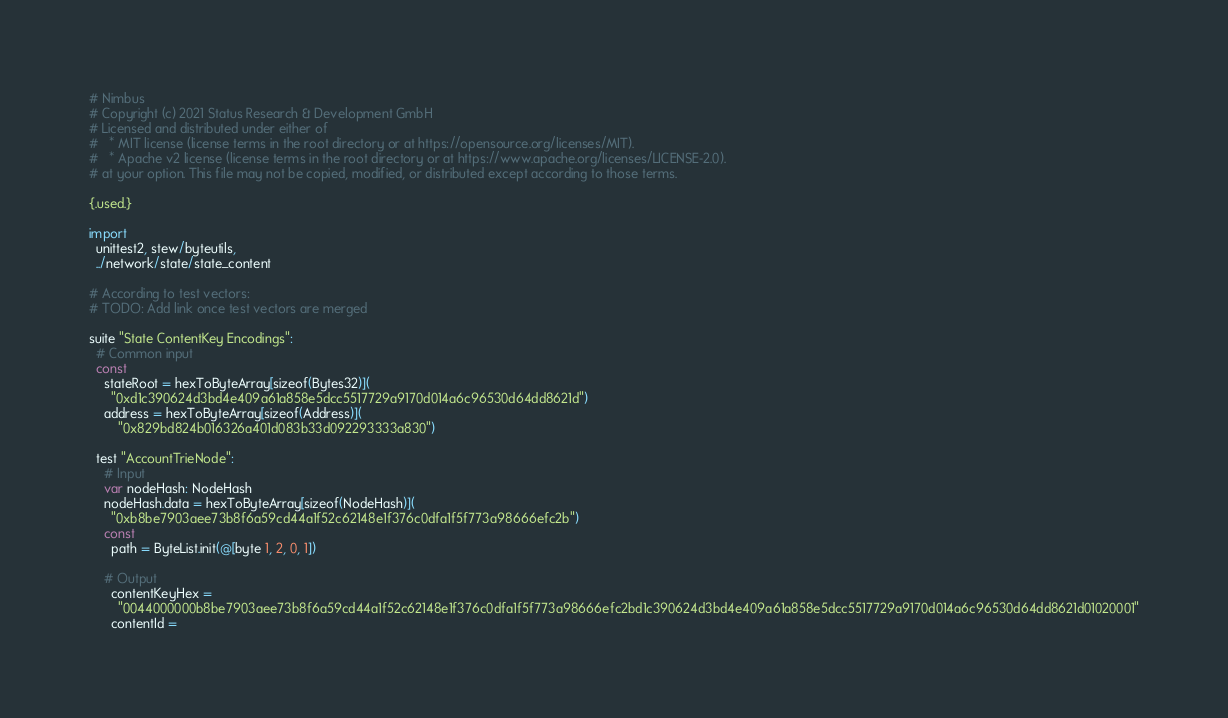Convert code to text. <code><loc_0><loc_0><loc_500><loc_500><_Nim_># Nimbus
# Copyright (c) 2021 Status Research & Development GmbH
# Licensed and distributed under either of
#   * MIT license (license terms in the root directory or at https://opensource.org/licenses/MIT).
#   * Apache v2 license (license terms in the root directory or at https://www.apache.org/licenses/LICENSE-2.0).
# at your option. This file may not be copied, modified, or distributed except according to those terms.

{.used.}

import
  unittest2, stew/byteutils,
  ../network/state/state_content

# According to test vectors:
# TODO: Add link once test vectors are merged

suite "State ContentKey Encodings":
  # Common input
  const
    stateRoot = hexToByteArray[sizeof(Bytes32)](
      "0xd1c390624d3bd4e409a61a858e5dcc5517729a9170d014a6c96530d64dd8621d")
    address = hexToByteArray[sizeof(Address)](
        "0x829bd824b016326a401d083b33d092293333a830")

  test "AccountTrieNode":
    # Input
    var nodeHash: NodeHash
    nodeHash.data = hexToByteArray[sizeof(NodeHash)](
      "0xb8be7903aee73b8f6a59cd44a1f52c62148e1f376c0dfa1f5f773a98666efc2b")
    const
      path = ByteList.init(@[byte 1, 2, 0, 1])

    # Output
      contentKeyHex =
        "0044000000b8be7903aee73b8f6a59cd44a1f52c62148e1f376c0dfa1f5f773a98666efc2bd1c390624d3bd4e409a61a858e5dcc5517729a9170d014a6c96530d64dd8621d01020001"
      contentId =</code> 